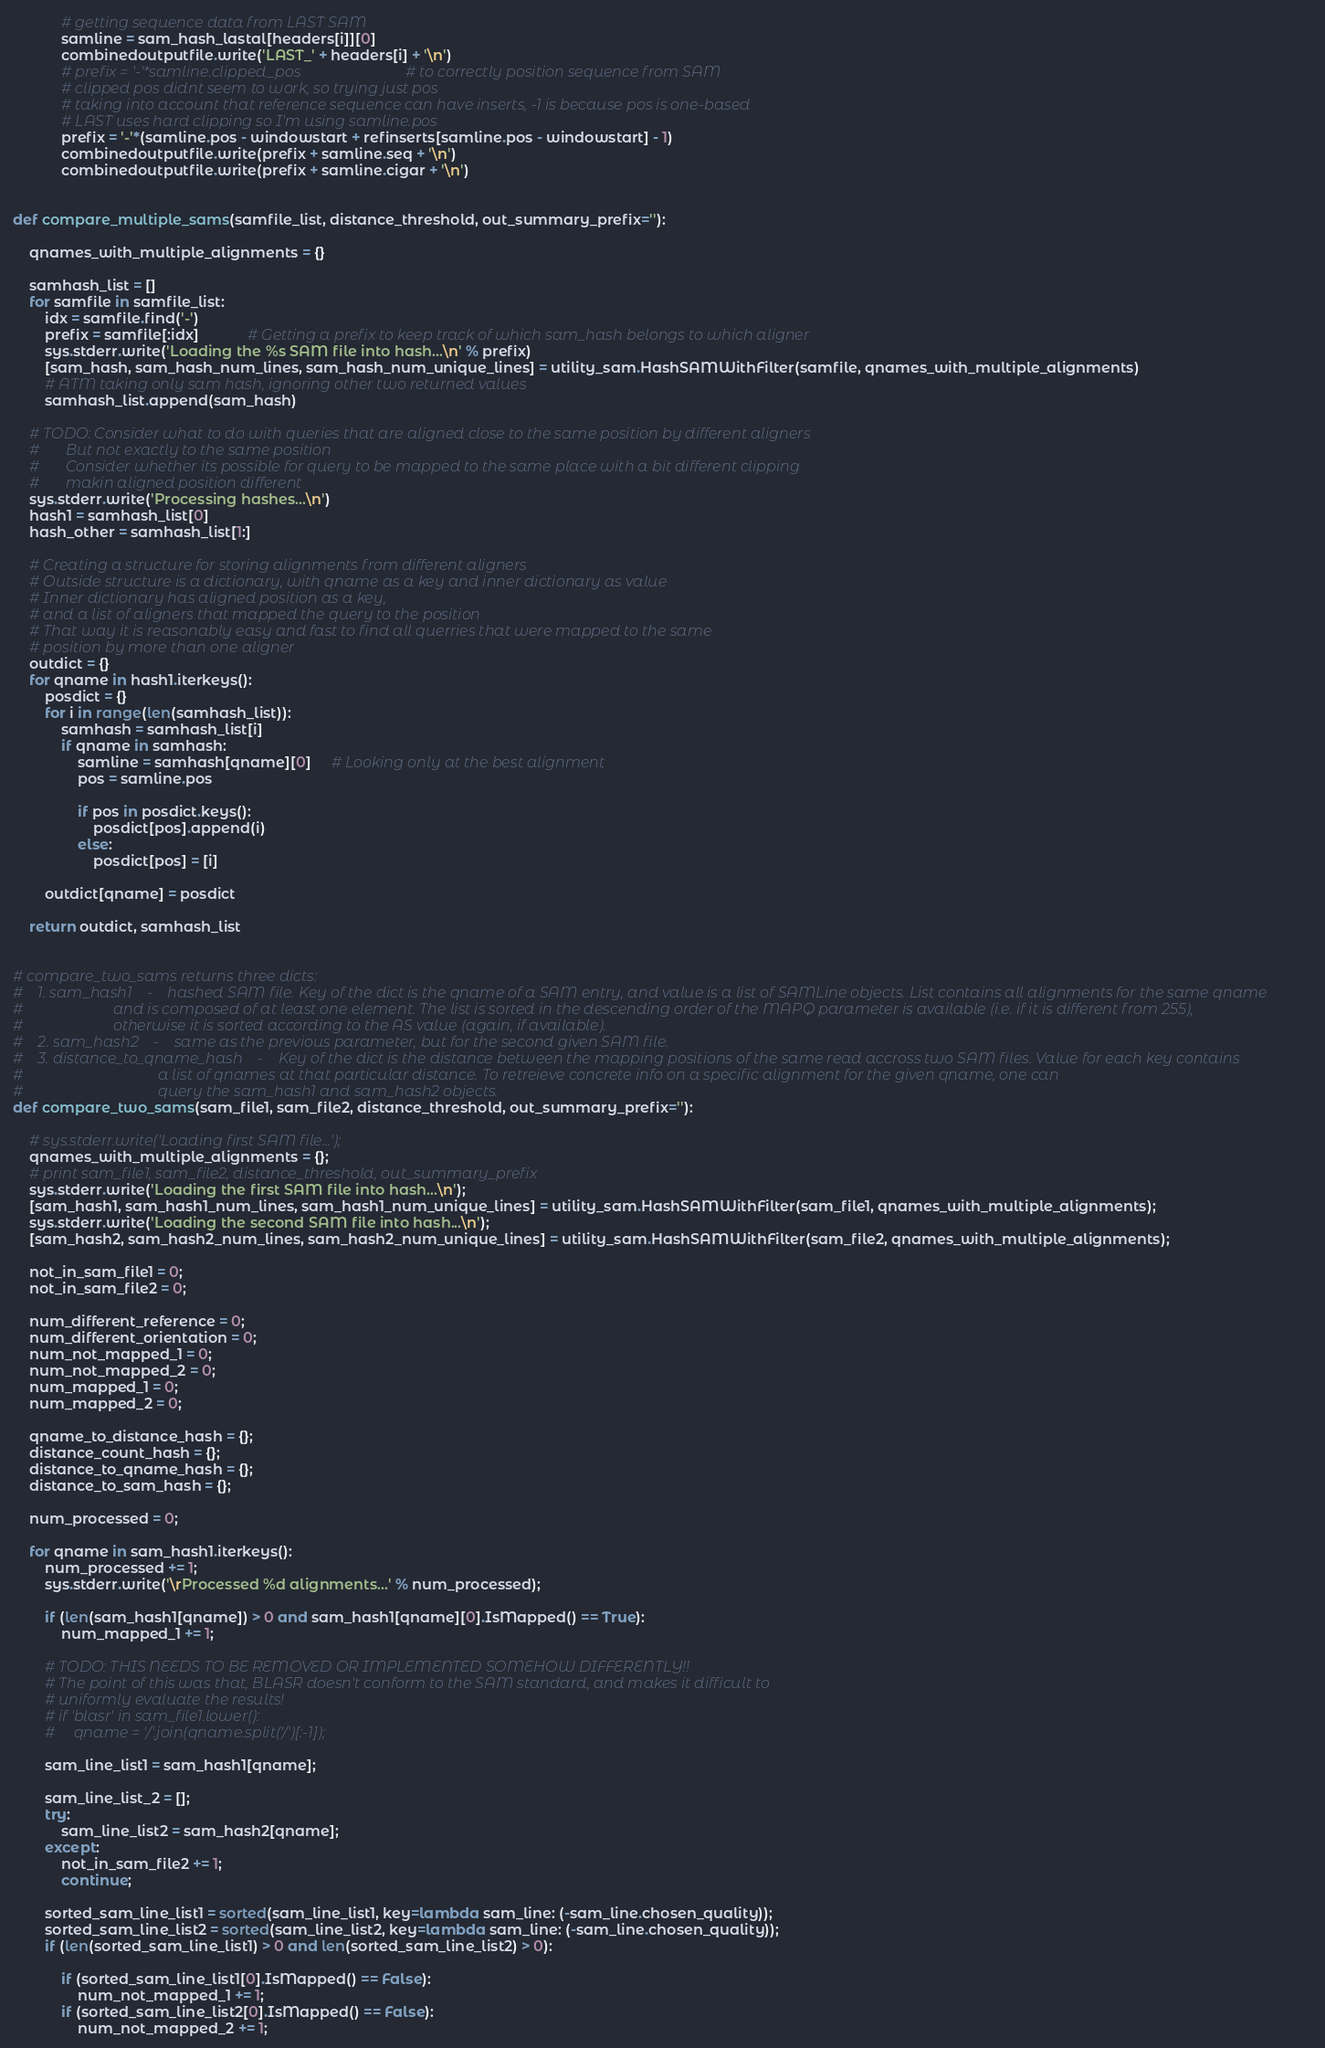<code> <loc_0><loc_0><loc_500><loc_500><_Python_>
            # getting sequence data from LAST SAM
            samline = sam_hash_lastal[headers[i]][0]
            combinedoutputfile.write('LAST_' + headers[i] + '\n')
            # prefix = '-'*samline.clipped_pos                            # to correctly position sequence from SAM
            # clipped pos didnt seem to work, so trying just pos
            # taking into account that reference sequence can have inserts, -1 is because pos is one-based
            # LAST uses hard clipping so I'm using samline.pos
            prefix = '-'*(samline.pos - windowstart + refinserts[samline.pos - windowstart] - 1)
            combinedoutputfile.write(prefix + samline.seq + '\n')
            combinedoutputfile.write(prefix + samline.cigar + '\n')


def compare_multiple_sams(samfile_list, distance_threshold, out_summary_prefix=''):

    qnames_with_multiple_alignments = {}

    samhash_list = []
    for samfile in samfile_list:
        idx = samfile.find('-')
        prefix = samfile[:idx]            # Getting a prefix to keep track of which sam_hash belongs to which aligner
        sys.stderr.write('Loading the %s SAM file into hash...\n' % prefix)
        [sam_hash, sam_hash_num_lines, sam_hash_num_unique_lines] = utility_sam.HashSAMWithFilter(samfile, qnames_with_multiple_alignments)
        # ATM taking only sam hash, ignoring other two returned values
        samhash_list.append(sam_hash)

    # TODO: Consider what to do with queries that are aligned close to the same position by different aligners
    #       But not exactly to the same position
    #       Consider whether its possible for query to be mapped to the same place with a bit different clipping
    #       makin aligned position different
    sys.stderr.write('Processing hashes...\n')
    hash1 = samhash_list[0]
    hash_other = samhash_list[1:]

    # Creating a structure for storing alignments from different aligners
    # Outside structure is a dictionary, with qname as a key and inner dictionary as value
    # Inner dictionary has aligned position as a key,
    # and a list of aligners that mapped the query to the position
    # That way it is reasonably easy and fast to find all querries that were mapped to the same
    # position by more than one aligner
    outdict = {}
    for qname in hash1.iterkeys():
        posdict = {}
        for i in range(len(samhash_list)):
            samhash = samhash_list[i]
            if qname in samhash:
                samline = samhash[qname][0]     # Looking only at the best alignment
                pos = samline.pos

                if pos in posdict.keys():
                    posdict[pos].append(i)
                else:
                    posdict[pos] = [i]

        outdict[qname] = posdict

    return outdict, samhash_list


# compare_two_sams returns three dicts:
#    1. sam_hash1    -    hashed SAM file. Key of the dict is the qname of a SAM entry, and value is a list of SAMLine objects. List contains all alignments for the same qname
#                        and is composed of at least one element. The list is sorted in the descending order of the MAPQ parameter is available (i.e. if it is different from 255),
#                        otherwise it is sorted according to the AS value (again, if available).
#    2. sam_hash2    -    same as the previous parameter, but for the second given SAM file.
#    3. distance_to_qname_hash    -    Key of the dict is the distance between the mapping positions of the same read accross two SAM files. Value for each key contains
#                                    a list of qnames at that particular distance. To retreieve concrete info on a specific alignment for the given qname, one can
#                                    query the sam_hash1 and sam_hash2 objects.
def compare_two_sams(sam_file1, sam_file2, distance_threshold, out_summary_prefix=''):

    # sys.stderr.write('Loading first SAM file...');
    qnames_with_multiple_alignments = {};
    # print sam_file1, sam_file2, distance_threshold, out_summary_prefix
    sys.stderr.write('Loading the first SAM file into hash...\n');
    [sam_hash1, sam_hash1_num_lines, sam_hash1_num_unique_lines] = utility_sam.HashSAMWithFilter(sam_file1, qnames_with_multiple_alignments);
    sys.stderr.write('Loading the second SAM file into hash...\n');
    [sam_hash2, sam_hash2_num_lines, sam_hash2_num_unique_lines] = utility_sam.HashSAMWithFilter(sam_file2, qnames_with_multiple_alignments);

    not_in_sam_file1 = 0;
    not_in_sam_file2 = 0;

    num_different_reference = 0;
    num_different_orientation = 0;
    num_not_mapped_1 = 0;
    num_not_mapped_2 = 0;
    num_mapped_1 = 0;
    num_mapped_2 = 0;

    qname_to_distance_hash = {};
    distance_count_hash = {};
    distance_to_qname_hash = {};
    distance_to_sam_hash = {};

    num_processed = 0;

    for qname in sam_hash1.iterkeys():
        num_processed += 1;
        sys.stderr.write('\rProcessed %d alignments...' % num_processed);

        if (len(sam_hash1[qname]) > 0 and sam_hash1[qname][0].IsMapped() == True):
            num_mapped_1 += 1;

        # TODO: THIS NEEDS TO BE REMOVED OR IMPLEMENTED SOMEHOW DIFFERENTLY!!
        # The point of this was that, BLASR doesn't conform to the SAM standard, and makes it difficult to
        # uniformly evaluate the results!
        # if 'blasr' in sam_file1.lower():
        #     qname = '/'.join(qname.split('/')[:-1]);

        sam_line_list1 = sam_hash1[qname];

        sam_line_list_2 = [];
        try:
            sam_line_list2 = sam_hash2[qname];
        except:
            not_in_sam_file2 += 1;
            continue;

        sorted_sam_line_list1 = sorted(sam_line_list1, key=lambda sam_line: (-sam_line.chosen_quality));
        sorted_sam_line_list2 = sorted(sam_line_list2, key=lambda sam_line: (-sam_line.chosen_quality));
        if (len(sorted_sam_line_list1) > 0 and len(sorted_sam_line_list2) > 0):

            if (sorted_sam_line_list1[0].IsMapped() == False):
                num_not_mapped_1 += 1;
            if (sorted_sam_line_list2[0].IsMapped() == False):
                num_not_mapped_2 += 1;</code> 